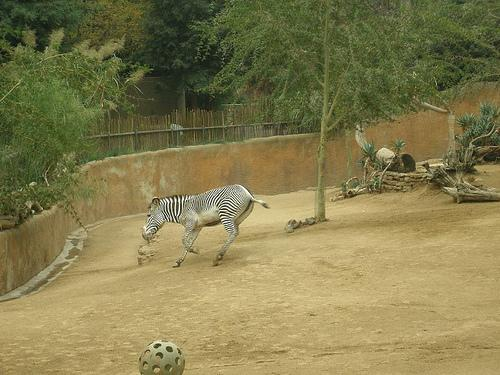Describe the primary element of the image and what it is doing, with an air of mystery. Intriguing as it may seem, a zebra of contrasting hues dashes across, bowing to greet the firmament below. Mention the central figure in the image and its actions using a poetic tone. Amidst the wild, a zebra dressed in monochrome gallops gracefully, bending to meet earth's embrace. Provide a brief description of the main subject in the image and its activity. A running zebra with black and white stripes is bending over towards the ground. Describe the chief subject in the image and its actions in a concise and direct manner. Black and white striped zebra: running and bending to touch the ground. Elaborate on the principal figure in the image and its actions, using a formal tone. The predominant subject of the image is a zebra adorned with black and white stripes, captured whilst it is in motion and bending towards the terrain beneath it. Give a short and simple description of the main subject in the image and its action. Zebra running and bending towards the ground. Express the main object in the image and its action, with a hint of excitement. Wow! Check out this zebra with black and white stripes sprinting and bending close to the ground! Briefly narrate about the main character in the image and its behavior using an informal tone. You know what, there's this zebra with black and white stripes just running around and bending over the ground. Provide an artistic interpretation of the primary character in the image and its actions. Dancing through the landscape, a zebra draped in the vibrant cloak of black and white sets in motion, plunging towards the welcoming arms of the earth. Write down the major object present in the image along with what it's doing, in a casual tone. Hey, there's a zebra with black and white stripes, looks like it's running and bending towards the ground. 